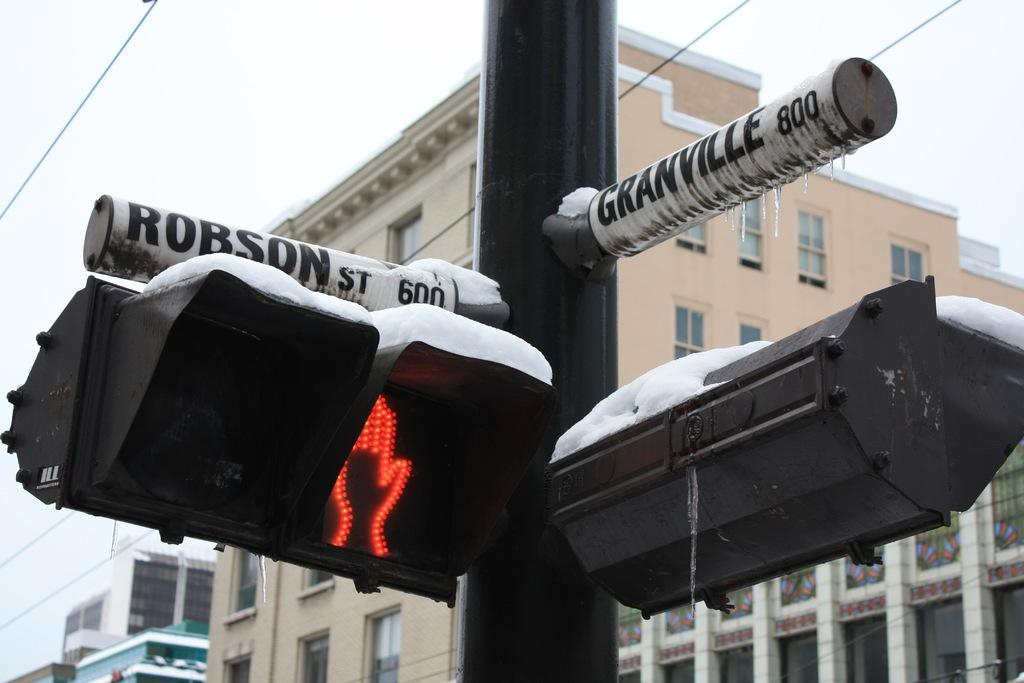What is located in front of the building in the image? There is a signal pole in front of the building in the image. What can be seen in the background of the image? The sky is visible in the background of the image. What type of dinner is being served on the twig in the image? There is no dinner or twig present in the image; it only features a signal pole in front of a building and the sky in the background. 